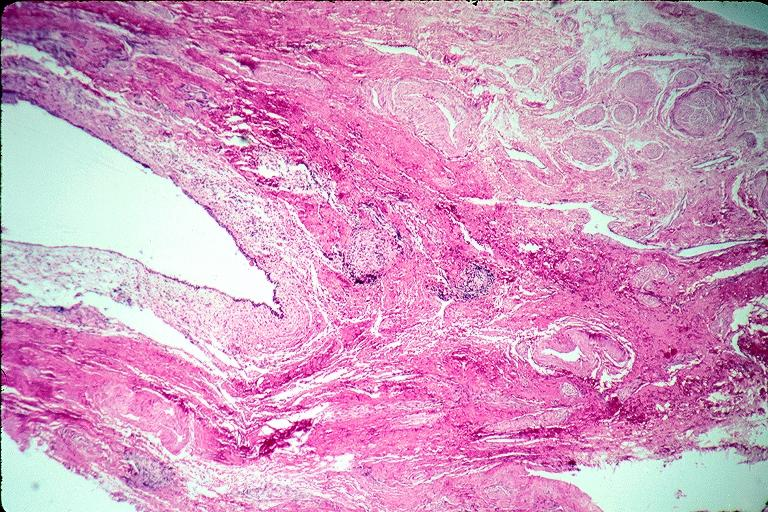where is this?
Answer the question using a single word or phrase. Oral 